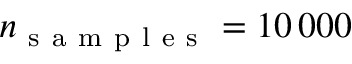Convert formula to latex. <formula><loc_0><loc_0><loc_500><loc_500>n _ { s a m p l e s } = 1 0 \, 0 0 0</formula> 